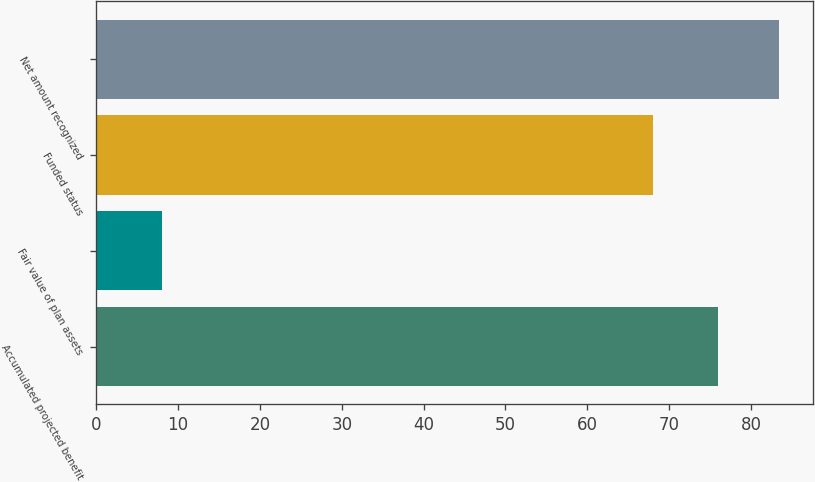<chart> <loc_0><loc_0><loc_500><loc_500><bar_chart><fcel>Accumulated projected benefit<fcel>Fair value of plan assets<fcel>Funded status<fcel>Net amount recognized<nl><fcel>76<fcel>8<fcel>68<fcel>83.4<nl></chart> 